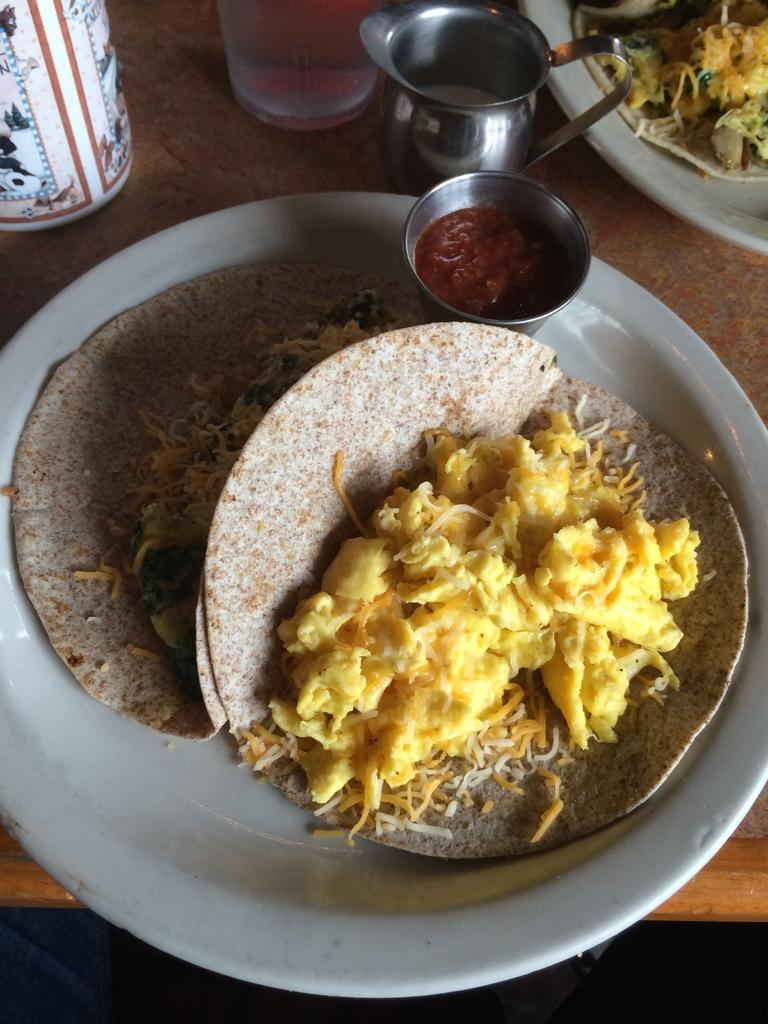What type of objects are present on the table in the image? There are plates with food items, a cup, a glass, and a mug on the table. What can be used for drinking in the image? The cup, glass, and mug can be used for drinking in the image. What is the setting of the image? The image may have been taken in a room, as the objects are on a table. What type of wren can be seen perched on the edge of the glass in the image? There is no wren present in the image; it only features plates with food items, a cup, a glass, and a mug on a table. How many boats are visible in the image? There are no boats present in the image. 